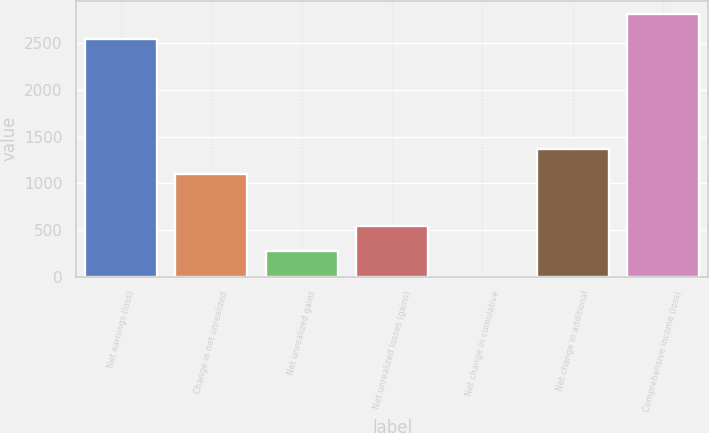Convert chart. <chart><loc_0><loc_0><loc_500><loc_500><bar_chart><fcel>Net earnings (loss)<fcel>Change in net unrealized<fcel>Net unrealized gains<fcel>Net unrealized losses (gains)<fcel>Net change in cumulative<fcel>Net change in additional<fcel>Comprehensive income (loss)<nl><fcel>2539<fcel>1096<fcel>275.5<fcel>549<fcel>2<fcel>1369.5<fcel>2812.5<nl></chart> 